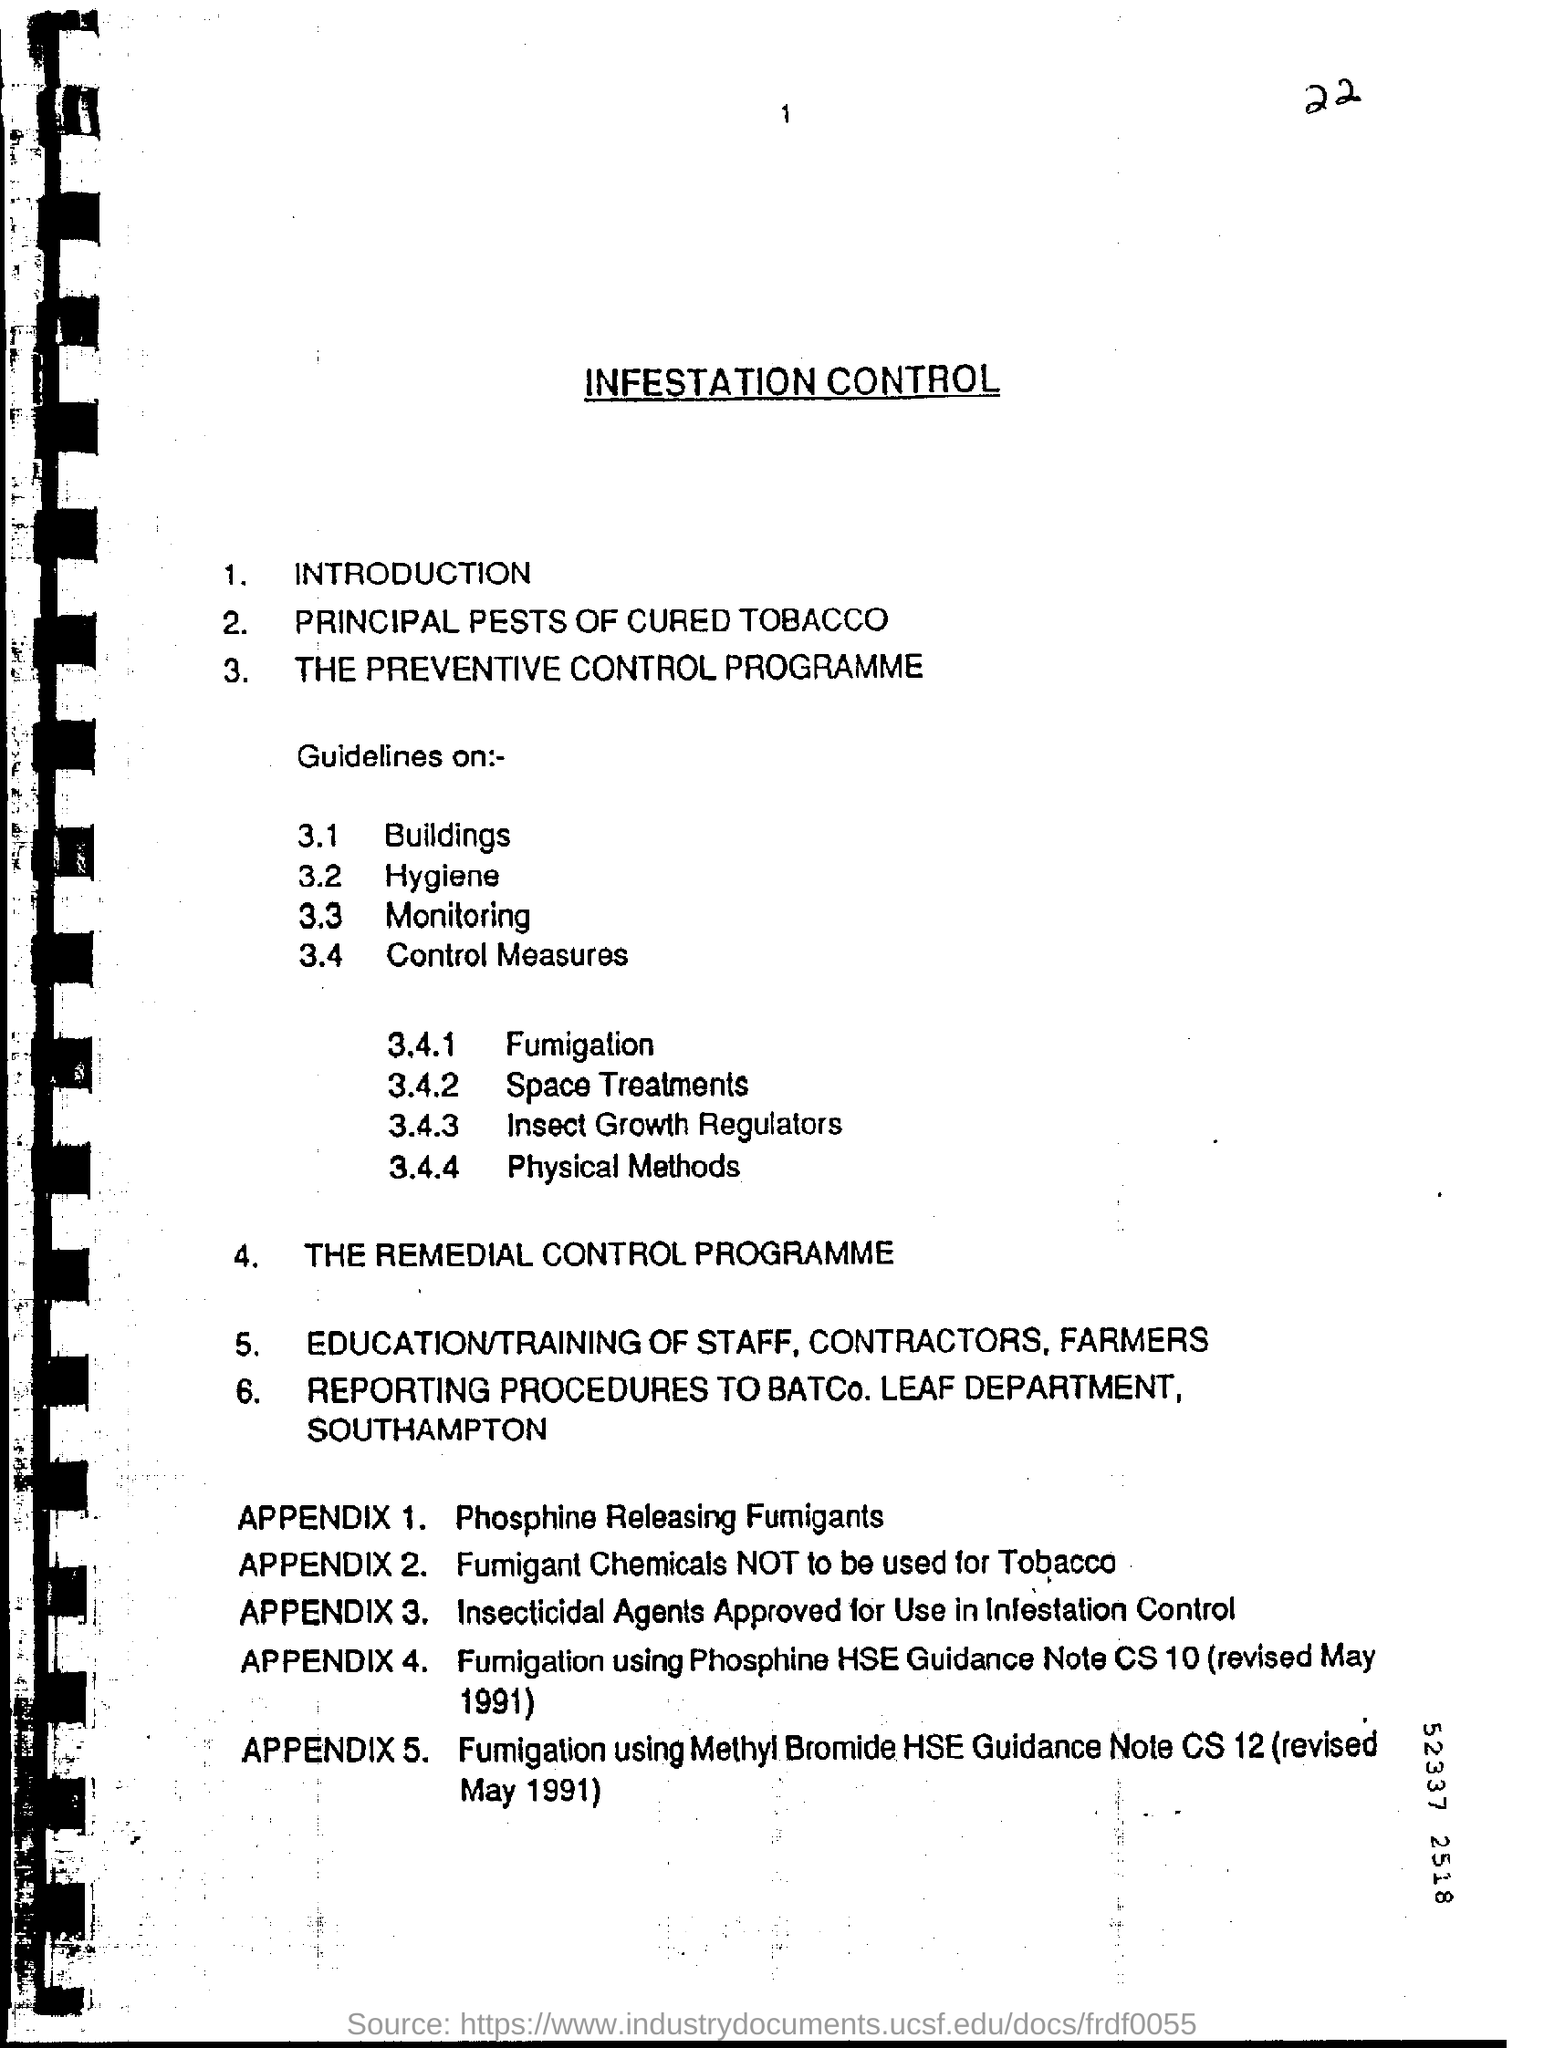Draw attention to some important aspects in this diagram. The item number 2 on this page is about the Principal Pests of cured Tobacco. Appendix 1 is a section that provides information on phosphine releasing fumigants. 3.4.1 is a topic that involves fumigation. The headline of this document is 'Infestation Control.' 